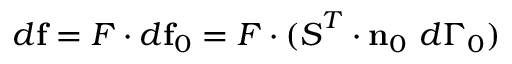Convert formula to latex. <formula><loc_0><loc_0><loc_500><loc_500>d f = { F } \cdot d f _ { 0 } = { F } \cdot ( { S } ^ { T } \cdot n _ { 0 } d \Gamma _ { 0 } )</formula> 